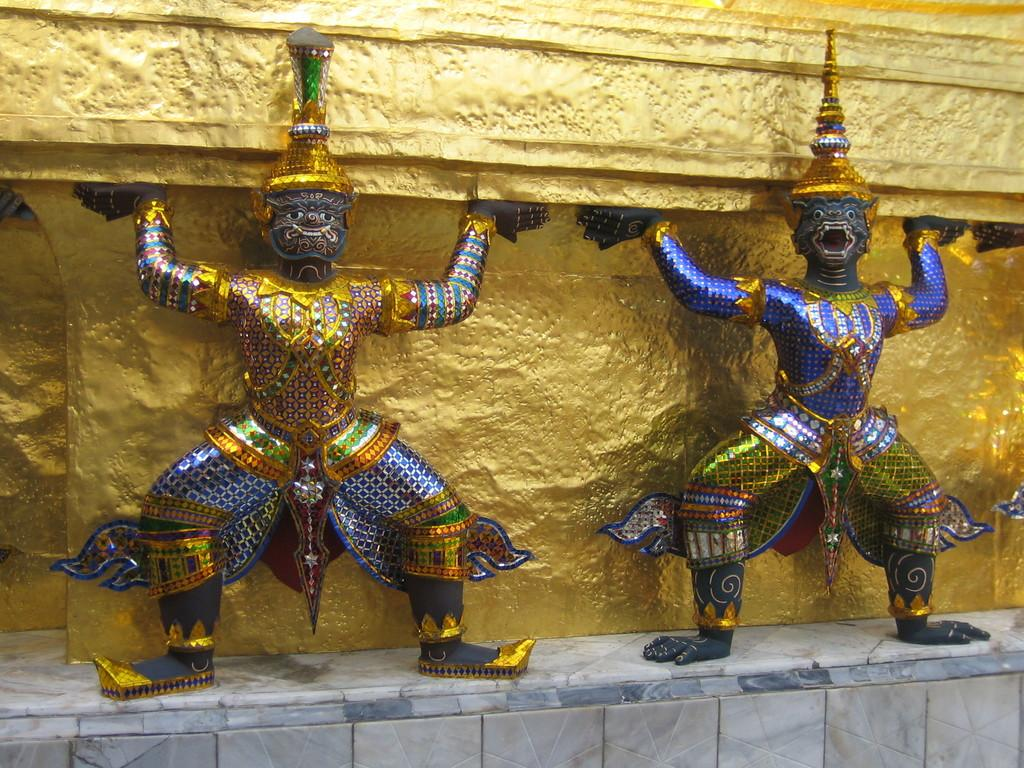What type of artwork is present in the image? There are sculptures in the image. Where are the sculptures located in relation to other elements in the image? The sculptures are in front of a wall. What type of reaction can be seen happening on the stove in the image? There is no stove present in the image, and therefore no reaction can be observed. 